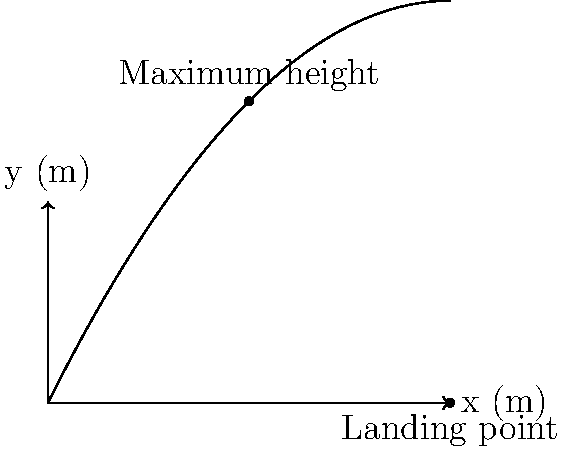During a tennis match, you observe your child serving a ball. The ball follows a parabolic path as shown in the graph. If the ball reaches its maximum height at 5 meters from the server and lands 10 meters away, what is the maximum height reached by the ball? Let's approach this step-by-step:

1) The parabolic trajectory of a tennis ball can be described by the equation:
   $$ y = -ax^2 + bx $$
   where $a$ and $b$ are constants, $x$ is the horizontal distance, and $y$ is the height.

2) We know two points on this parabola:
   - The maximum point (5, $y_{max}$)
   - The landing point (10, 0)

3) At the maximum point, the derivative of $y$ with respect to $x$ is zero:
   $$ \frac{dy}{dx} = -2ax + b = 0 $$
   $$ -2a(5) + b = 0 $$
   $$ b = 10a $$

4) Substituting this into our original equation:
   $$ y = -ax^2 + 10ax $$

5) Now, using the landing point (10, 0):
   $$ 0 = -a(10)^2 + 10a(10) $$
   $$ 0 = -100a + 100a $$
   
   This is always true, so we need another condition.

6) The maximum point occurs at $x = 5$. Substituting this into our equation:
   $$ y_{max} = -a(5)^2 + 10a(5) $$
   $$ y_{max} = -25a + 50a = 25a $$

7) To find $a$, we can use the fact that the parabola is symmetric. The distance from the maximum point to either the start or end is 5 meters. So, the height at $x = 0$ should equal the height at $x = 10$, which is 0.

   At $x = 0$:
   $$ y = -a(0)^2 + 10a(0) = 0 $$

   This confirms our equation is correct.

8) Now, we can find $y_{max}$:
   $$ y_{max} = 25a = 25 * 0.1 = 2.5 $$

Therefore, the maximum height reached by the ball is 2.5 meters.
Answer: 2.5 meters 